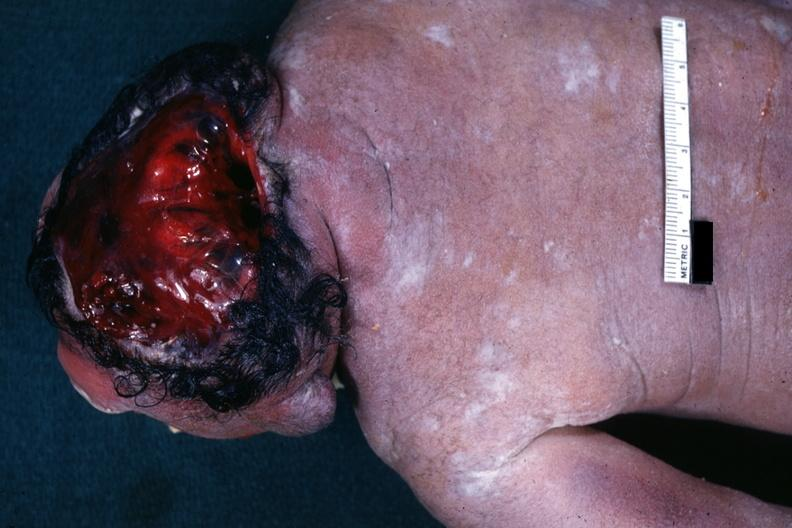s anencephaly present?
Answer the question using a single word or phrase. Yes 